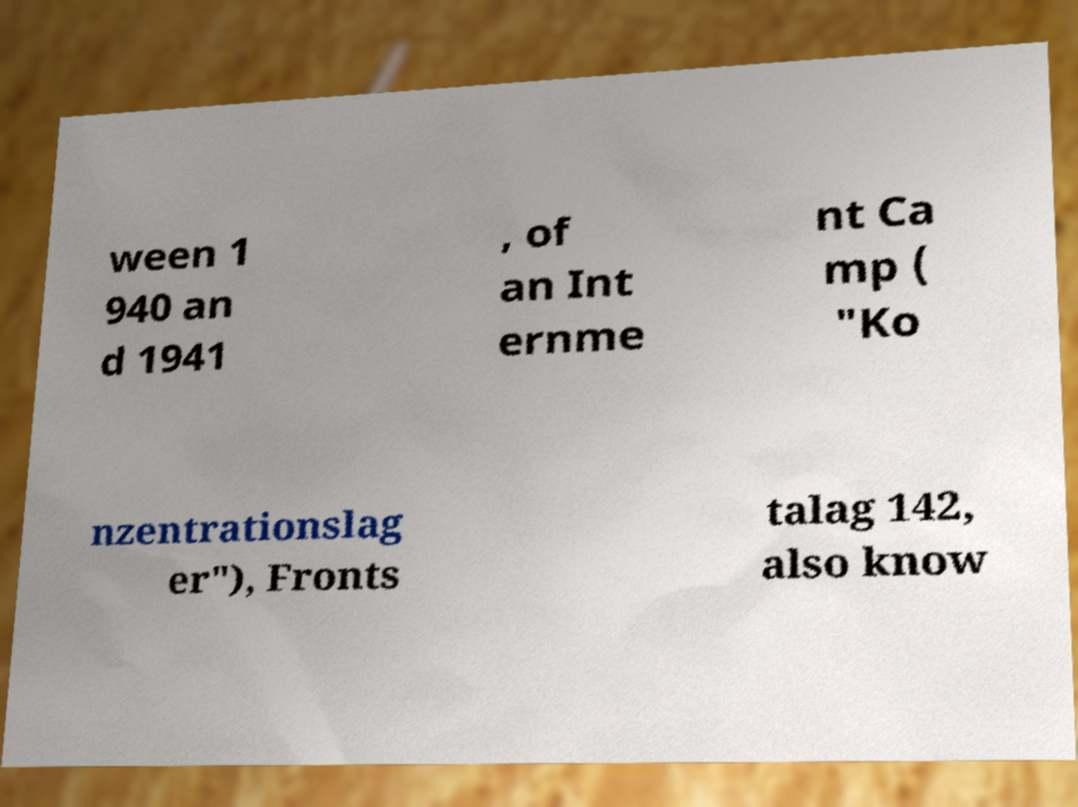Please read and relay the text visible in this image. What does it say? ween 1 940 an d 1941 , of an Int ernme nt Ca mp ( "Ko nzentrationslag er"), Fronts talag 142, also know 